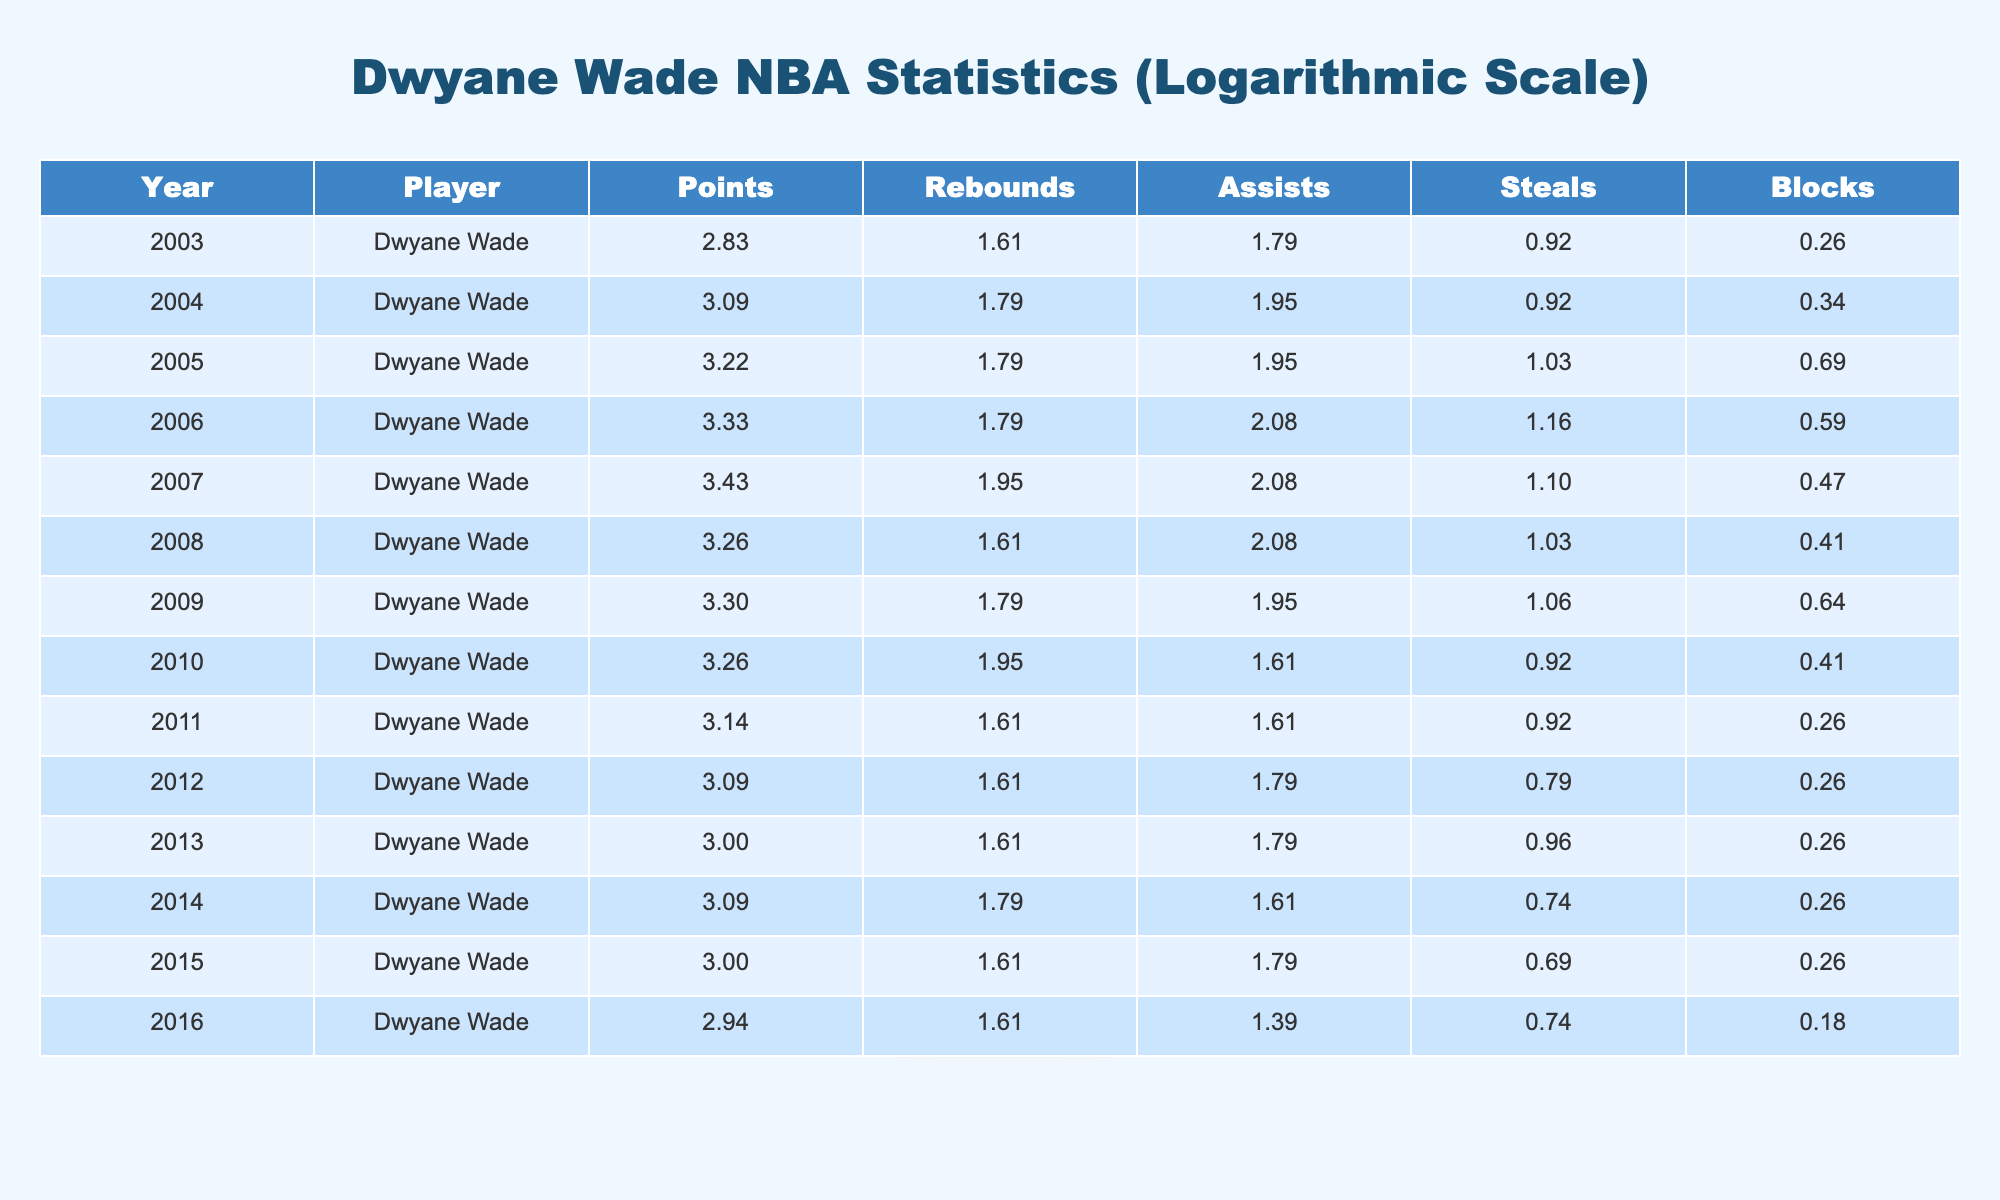What was Dwyane Wade's highest points per game in a single season? In the table, the highest points scored by Dwyane Wade in a single season is 30, which occurred in 2007.
Answer: 30 In which year did Dwyane Wade average the most rebounds per game? The year Dwyane Wade averaged the most rebounds per game is 2007, where he had an average of 6 rebounds.
Answer: 2007 What is the total number of assists Dwyane Wade had from 2003 to 2006? To find the total assists from 2003 to 2006, we add the assists from those years: 5 + 6 + 7 + 6 = 24.
Answer: 24 Did Dwyane Wade have a higher assists average in 2006 or 2007? In 2006, Dwyane Wade had 7 assists, while in 2007 he had 7 assists as well. Therefore, the averages are equal.
Answer: No What was the average number of steals per game for Dwyane Wade from 2008 to 2010? To calculate the average, we sum the steals from 2008 to 2010: 1.8 + 1.5 + 1.5 = 4.8, then divide by 3, which gives us 4.8 / 3 = 1.6.
Answer: 1.6 How many seasons did Dwyane Wade average over 25 points per game? By reviewing the table, Dwyane Wade averaged over 25 points in the seasons 2005, 2006, and 2007, which totals to 3 seasons.
Answer: 3 Was there any season where Dwyane Wade recorded more blocks than he did steals? In the year 2005, Dwyane Wade had 1 block while his steals were 1.8; therefore, he did not record more blocks than steals that season. This is true for all subsequently listed years as well: 2006, 2007, and 2009 had steals greater than blocks.
Answer: No What is the difference in average points per game between Wade's peak year and his lowest year? The peak year for points per game was 30 in 2007, and the lowest points were 16 in 2003. The difference is 30 - 16 = 14.
Answer: 14 What year did Dwyane Wade first surpass 20 points per game? Dwyane Wade first surpassed 20 points per game in the year 2004 when he averaged 21 points.
Answer: 2004 